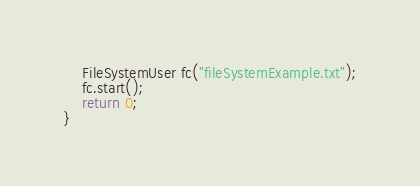Convert code to text. <code><loc_0><loc_0><loc_500><loc_500><_C++_>	FileSystemUser fc("fileSystemExample.txt");
	fc.start();
	return 0;
}</code> 